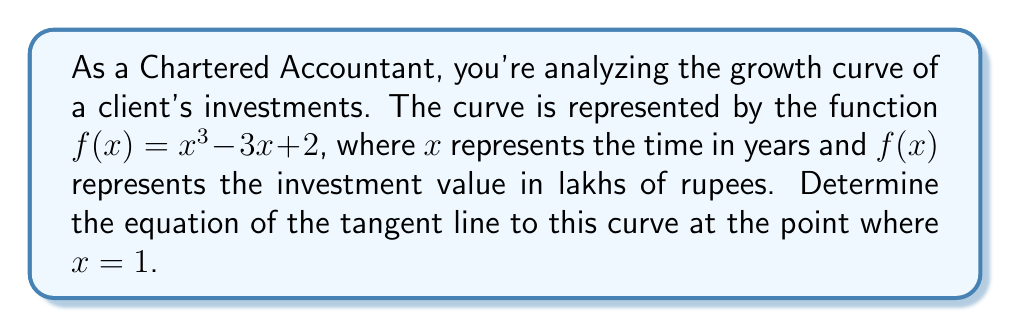Provide a solution to this math problem. To find the equation of the tangent line, we'll follow these steps:

1) The general equation of a tangent line is $y - y_1 = m(x - x_1)$, where $(x_1, y_1)$ is the point of tangency and $m$ is the slope of the tangent line.

2) We know $x_1 = 1$. Let's find $y_1$:
   $y_1 = f(1) = 1^3 - 3(1) + 2 = 1 - 3 + 2 = 0$
   So, the point of tangency is $(1, 0)$.

3) To find the slope $m$, we need to calculate the derivative of $f(x)$ and evaluate it at $x = 1$:
   $f'(x) = 3x^2 - 3$
   $m = f'(1) = 3(1)^2 - 3 = 3 - 3 = 0$

4) Now we have all the components to form the equation of the tangent line:
   $y - 0 = 0(x - 1)$

5) Simplify:
   $y = 0$

This makes sense geometrically, as the tangent line at $(1, 0)$ is horizontal, coinciding with the x-axis.
Answer: $y = 0$ 